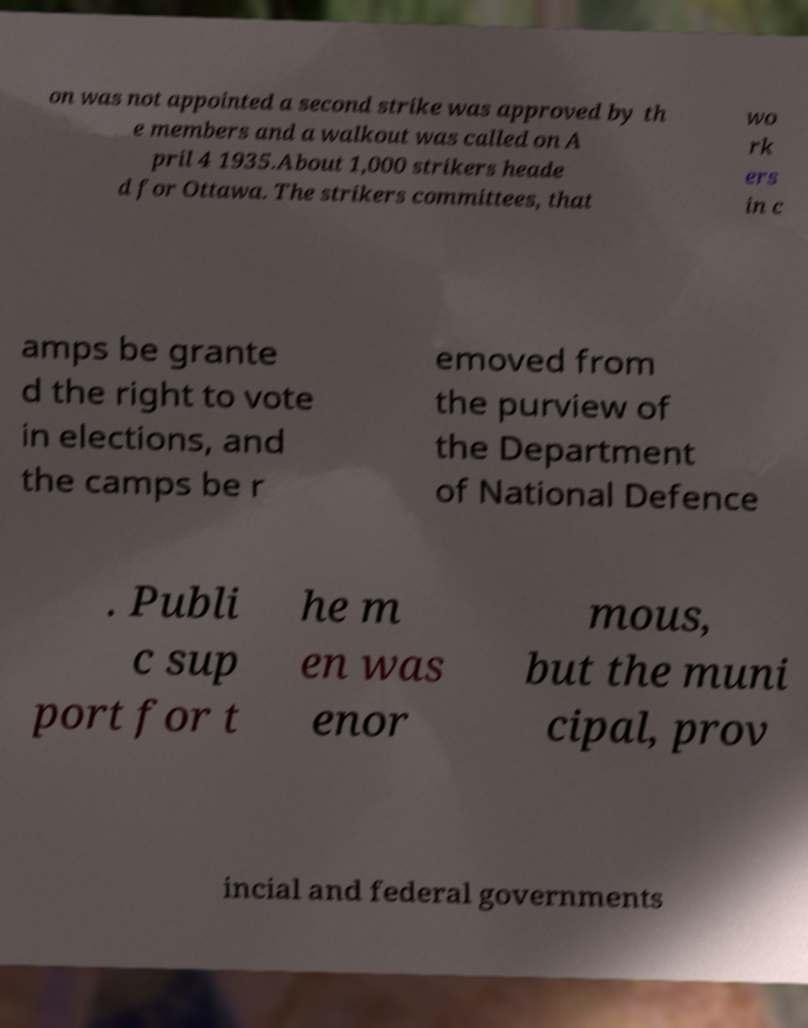Could you assist in decoding the text presented in this image and type it out clearly? on was not appointed a second strike was approved by th e members and a walkout was called on A pril 4 1935.About 1,000 strikers heade d for Ottawa. The strikers committees, that wo rk ers in c amps be grante d the right to vote in elections, and the camps be r emoved from the purview of the Department of National Defence . Publi c sup port for t he m en was enor mous, but the muni cipal, prov incial and federal governments 